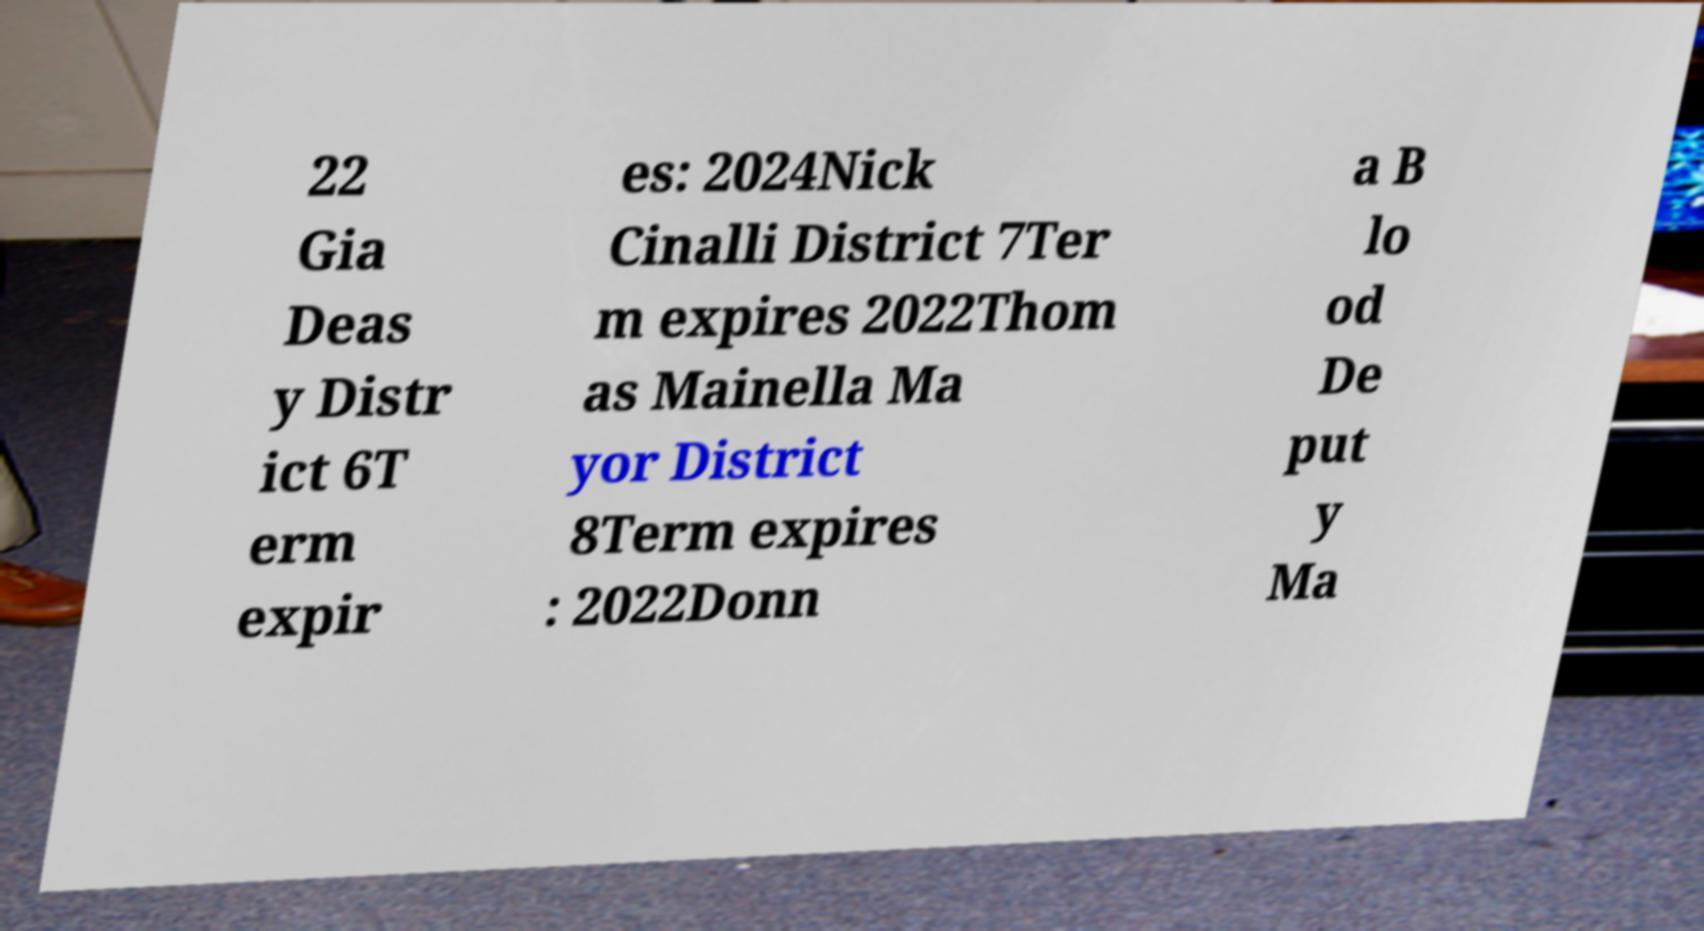Could you assist in decoding the text presented in this image and type it out clearly? 22 Gia Deas y Distr ict 6T erm expir es: 2024Nick Cinalli District 7Ter m expires 2022Thom as Mainella Ma yor District 8Term expires : 2022Donn a B lo od De put y Ma 